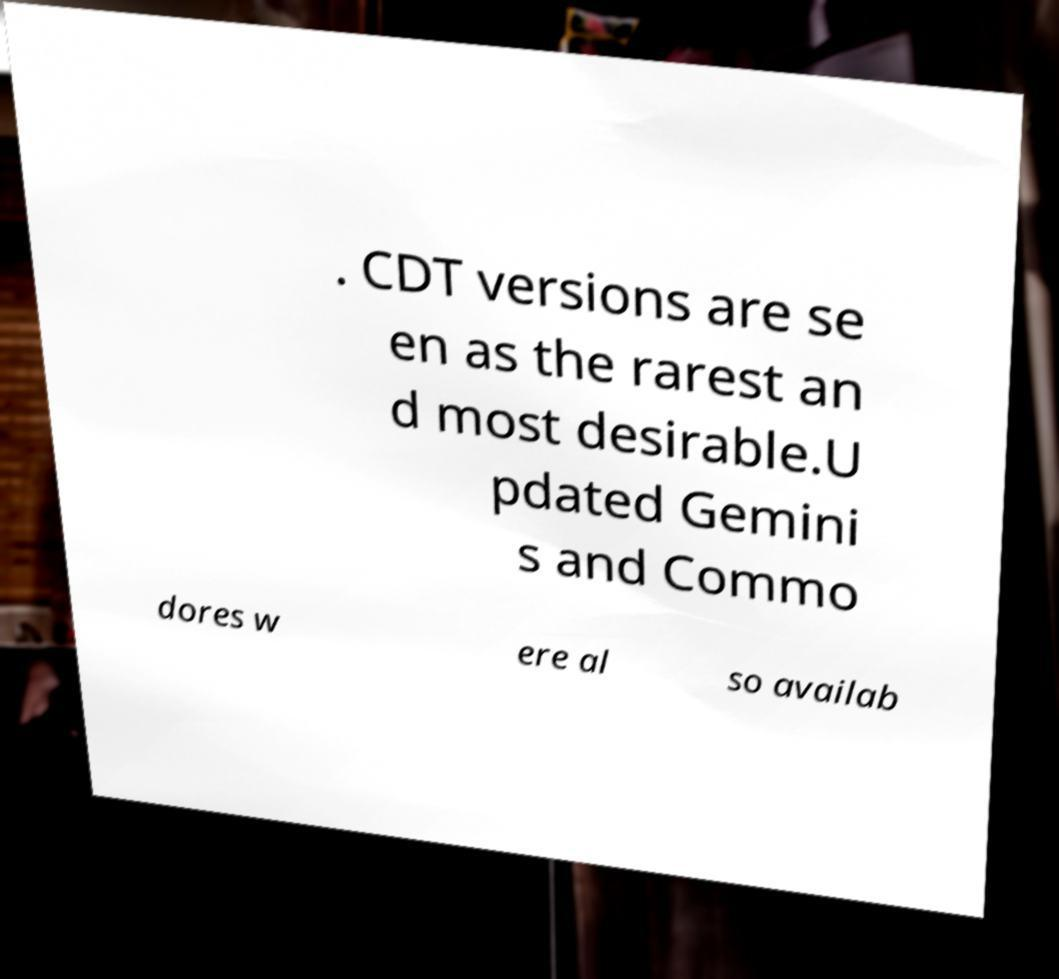Can you read and provide the text displayed in the image?This photo seems to have some interesting text. Can you extract and type it out for me? . CDT versions are se en as the rarest an d most desirable.U pdated Gemini s and Commo dores w ere al so availab 